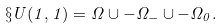Convert formula to latex. <formula><loc_0><loc_0><loc_500><loc_500>\S U ( 1 , 1 ) = \Omega \cup - \Omega _ { - } \cup - \Omega _ { 0 } .</formula> 